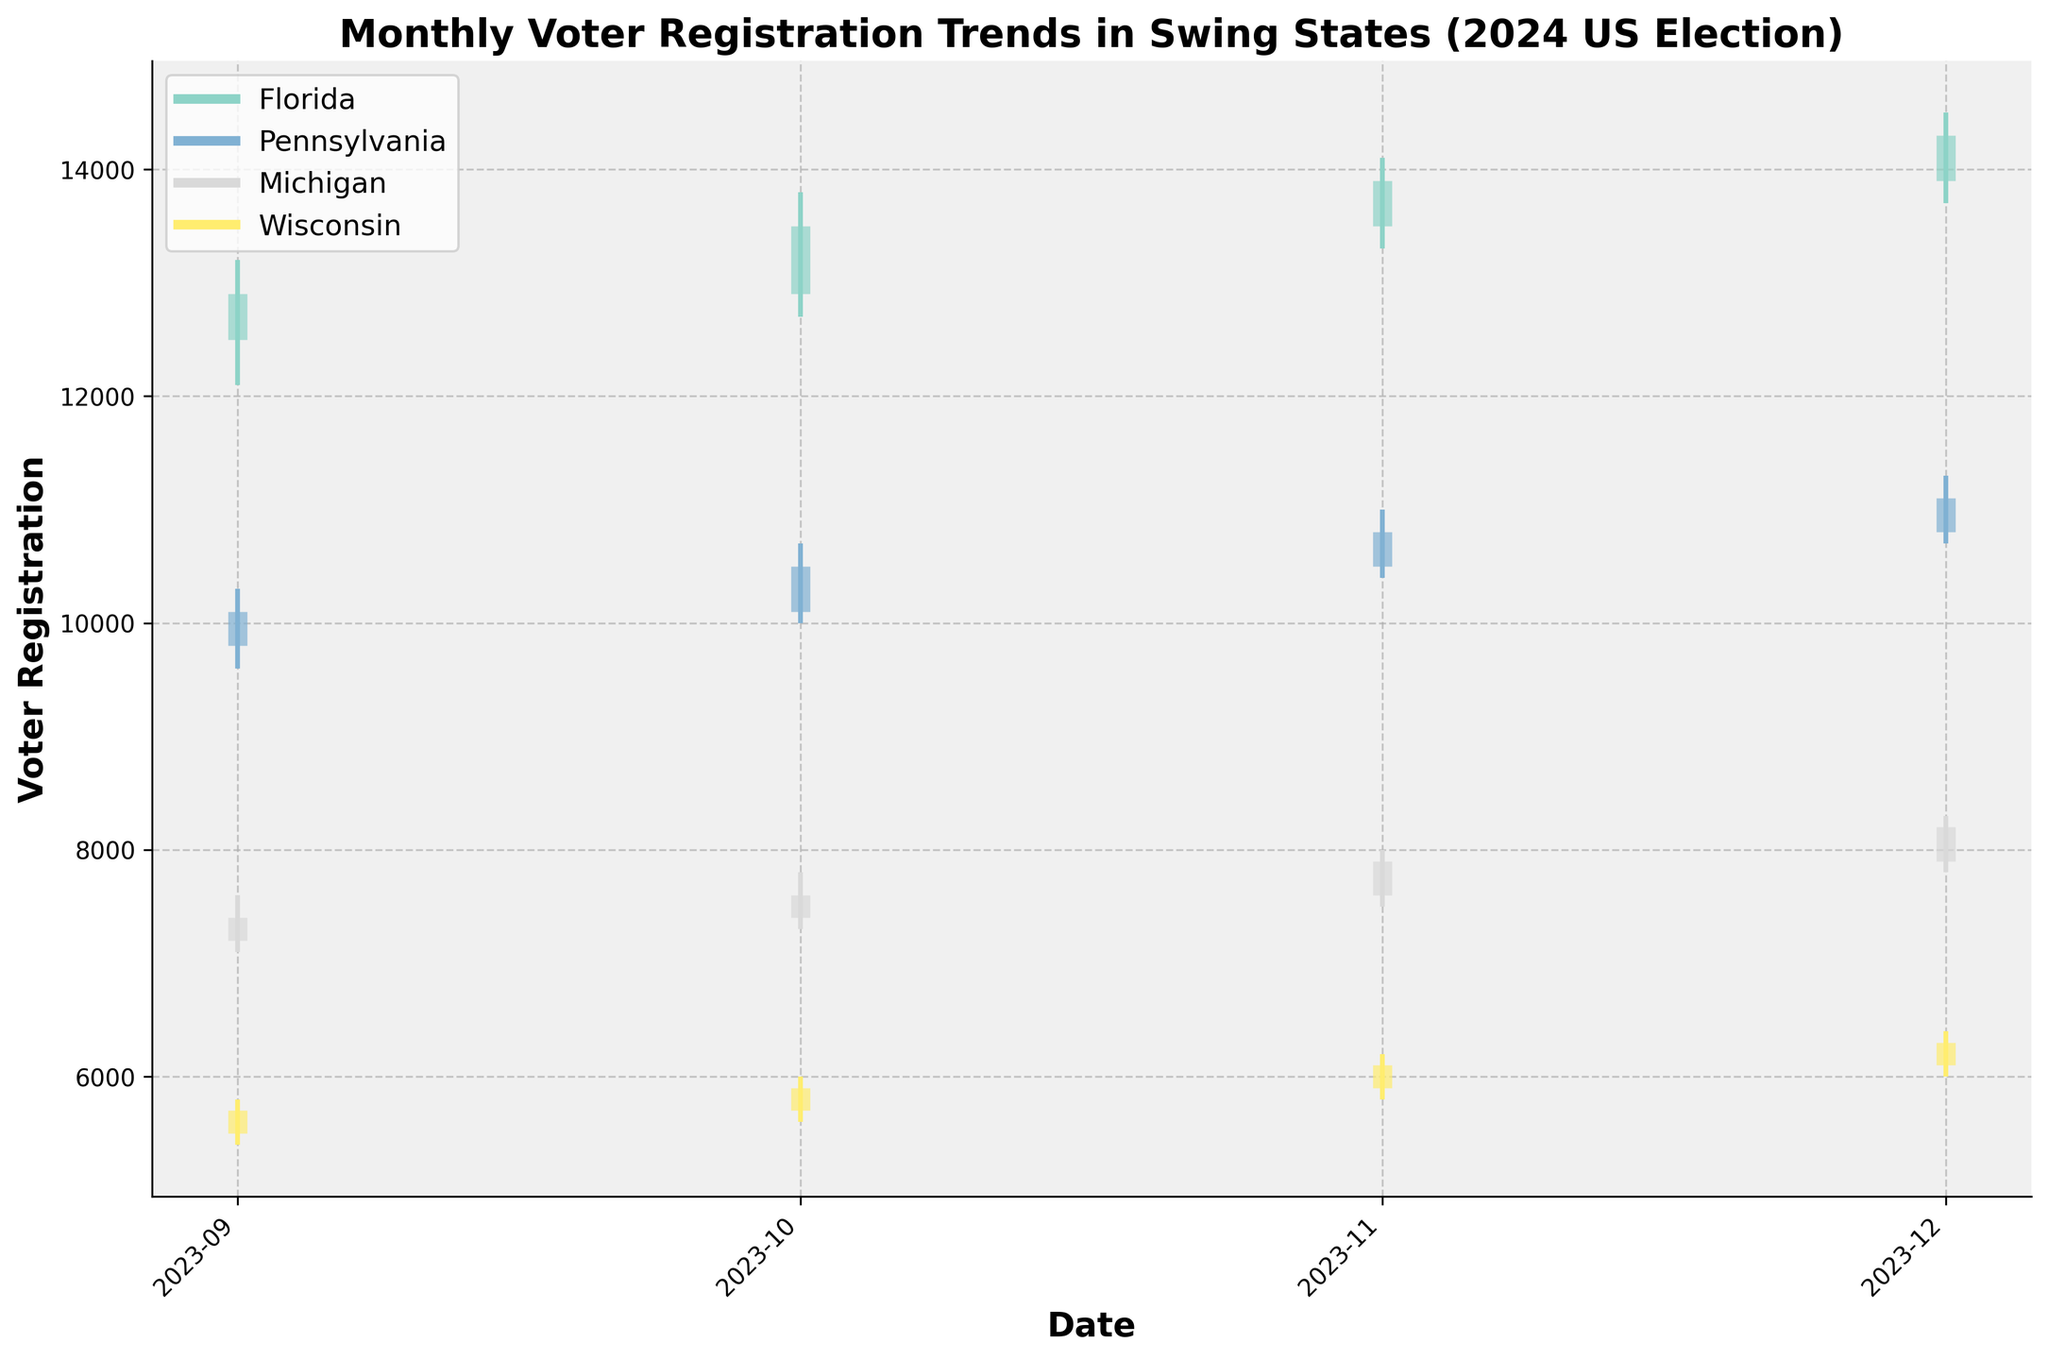what is the title of the figure? The title of the figure is prominently displayed at the top of the plot, providing a succinct description of the data being visualized.
Answer: Monthly Voter Registration Trends in Swing States (2024 US Election) What is the general trend in voter registration in Florida from September to December 2024? Observing the close values, we can see them steadily increasing each month: 12900 (Sep), 13500 (Oct), 13900 (Nov), and 14300 (Dec). This suggests a general upward trend in voter registration numbers.
Answer: Upward trend Which state has the highest closing voter registration value in December 2024? Examining the 'Close' values for December across all states, Pennsylvania has the highest value at 11100.
Answer: Pennsylvania What is the difference in the highest ('High') voter registration value between September and December for Wisconsin? The highest values for Wisconsin are 5800 (Sep) and 6400 (Dec). The difference is calculated as 6400 - 5800.
Answer: 600 How does the voter registration trend in Michigan compare to Pennsylvania from September to December 2024? Both states exhibit an upward trend in voter registration but at different magnitudes. Michigan's close values rise from 7400 (Sep) to 8200 (Dec), while Pennsylvania's values rise from 10100 (Sep) to 11100 (Dec). Both show an increasing trend, but Michigan increases by 800 and Pennsylvania by 1000.
Answer: Both upward; Pennsylvania by 1000, Michigan by 800 Which month saw the largest increase in Florida's voter registration numbers, and by how much? Looking at the 'Close' values for Florida, the largest increase was from October (13500) to November (13900), with a difference of 400.
Answer: November, 400 What is the average closing voter registration value in September 2024 across all four states? To find the average, sum the close values of all states in September (12900 + 10100 + 7400 + 5700) and divide by 4. The sum is 36100, and the average is 36100 / 4.
Answer: 9025 Which state has the smallest range (difference between high and low) in October 2024? Calculate the range for each state in October: Florida (13800-12700=1100), Pennsylvania (10700-10000=700), Michigan (7800-7300=500), Wisconsin (6000-5600=400). Wisconsin has the smallest range.
Answer: Wisconsin What is the overall trend of voter registration in Wisconsin from September to December 2024? Observing the 'Close' values for Wisconsin, we see: 5700 (Sep), 5900 (Oct), 6100 (Nov), and 6300 (Dec). This shows a consistent upward trend in voter registration numbers.
Answer: Upward trend 